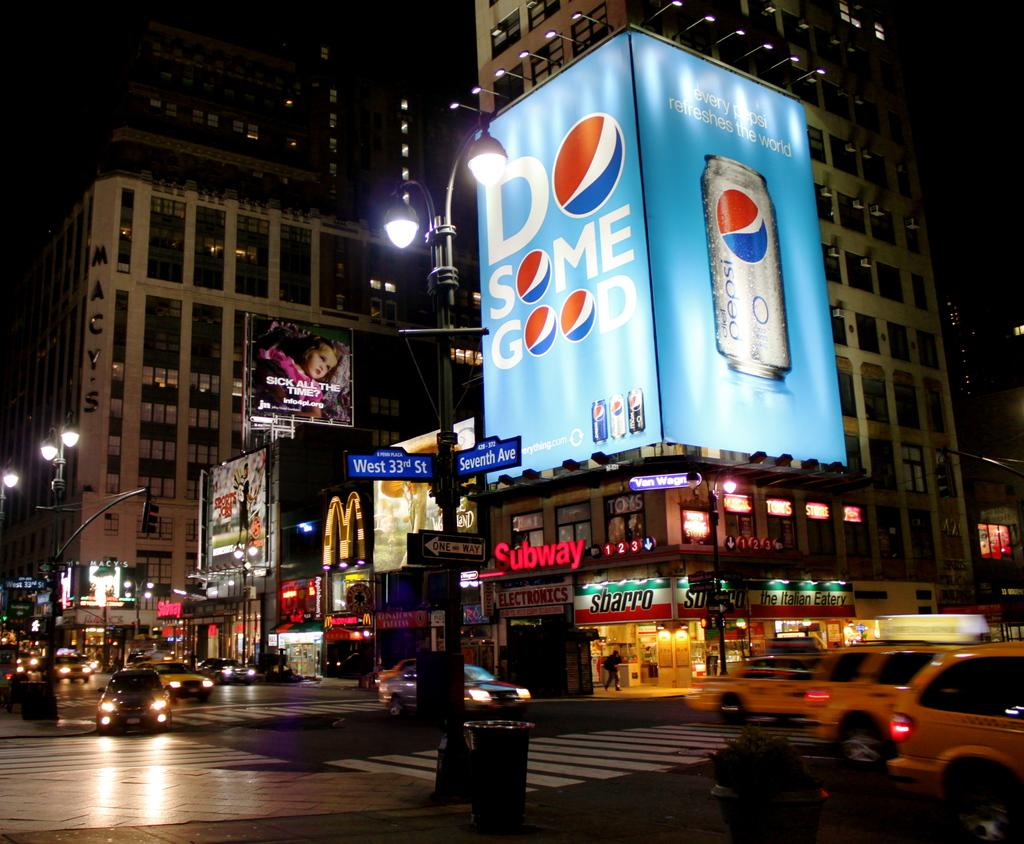<image>
Describe the image concisely. A downtown intersection at night has a sign that says Subway on the corner. 